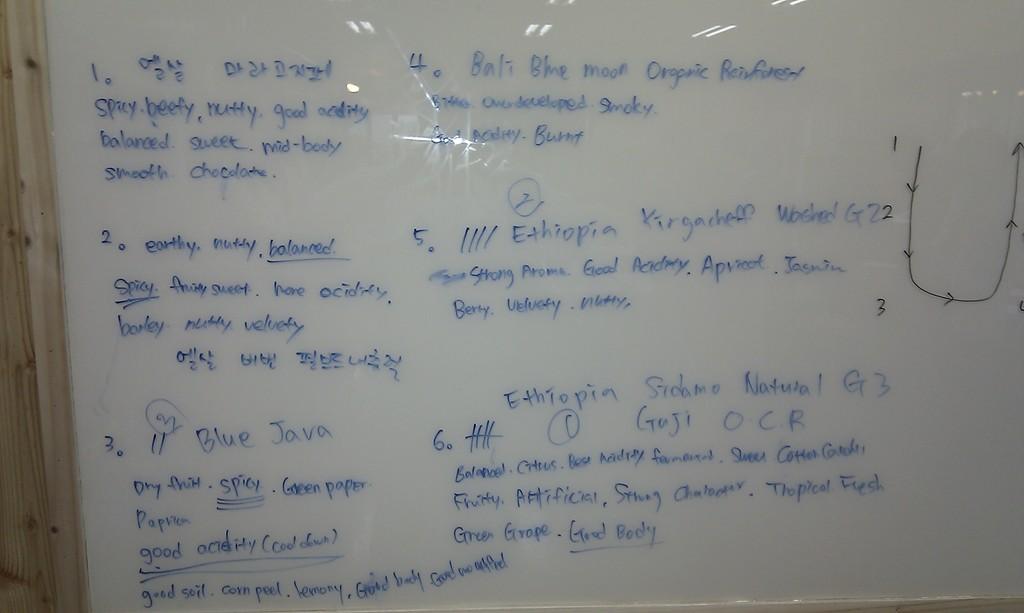Is it english or a differnt language?
Ensure brevity in your answer.  English. 